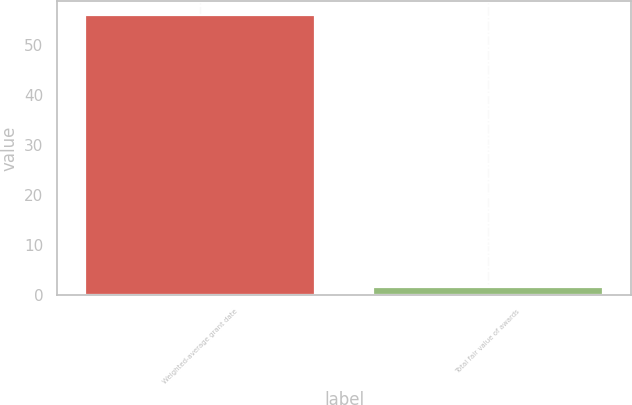Convert chart to OTSL. <chart><loc_0><loc_0><loc_500><loc_500><bar_chart><fcel>Weighted-average grant date<fcel>Total fair value of awards<nl><fcel>55.93<fcel>1.7<nl></chart> 